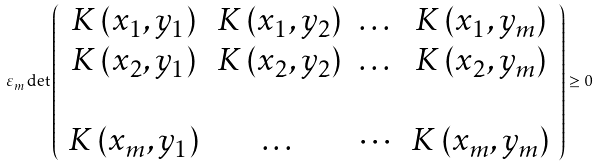<formula> <loc_0><loc_0><loc_500><loc_500>\varepsilon _ { m } \det \left ( \begin{array} { c c c c } K \left ( x _ { 1 } , y _ { 1 } \right ) & K \left ( x _ { 1 } , y _ { 2 } \right ) & \dots & K \left ( x _ { 1 } , y _ { m } \right ) \\ K \left ( x _ { 2 } , y _ { 1 } \right ) & K \left ( x _ { 2 } , y _ { 2 } \right ) & \dots & K \left ( x _ { 2 } , y _ { m } \right ) \\ & & & \\ K \left ( x _ { m } , y _ { 1 } \right ) & \dots & \cdots & K \left ( x _ { m } , y _ { m } \right ) \end{array} \right ) \geq 0</formula> 